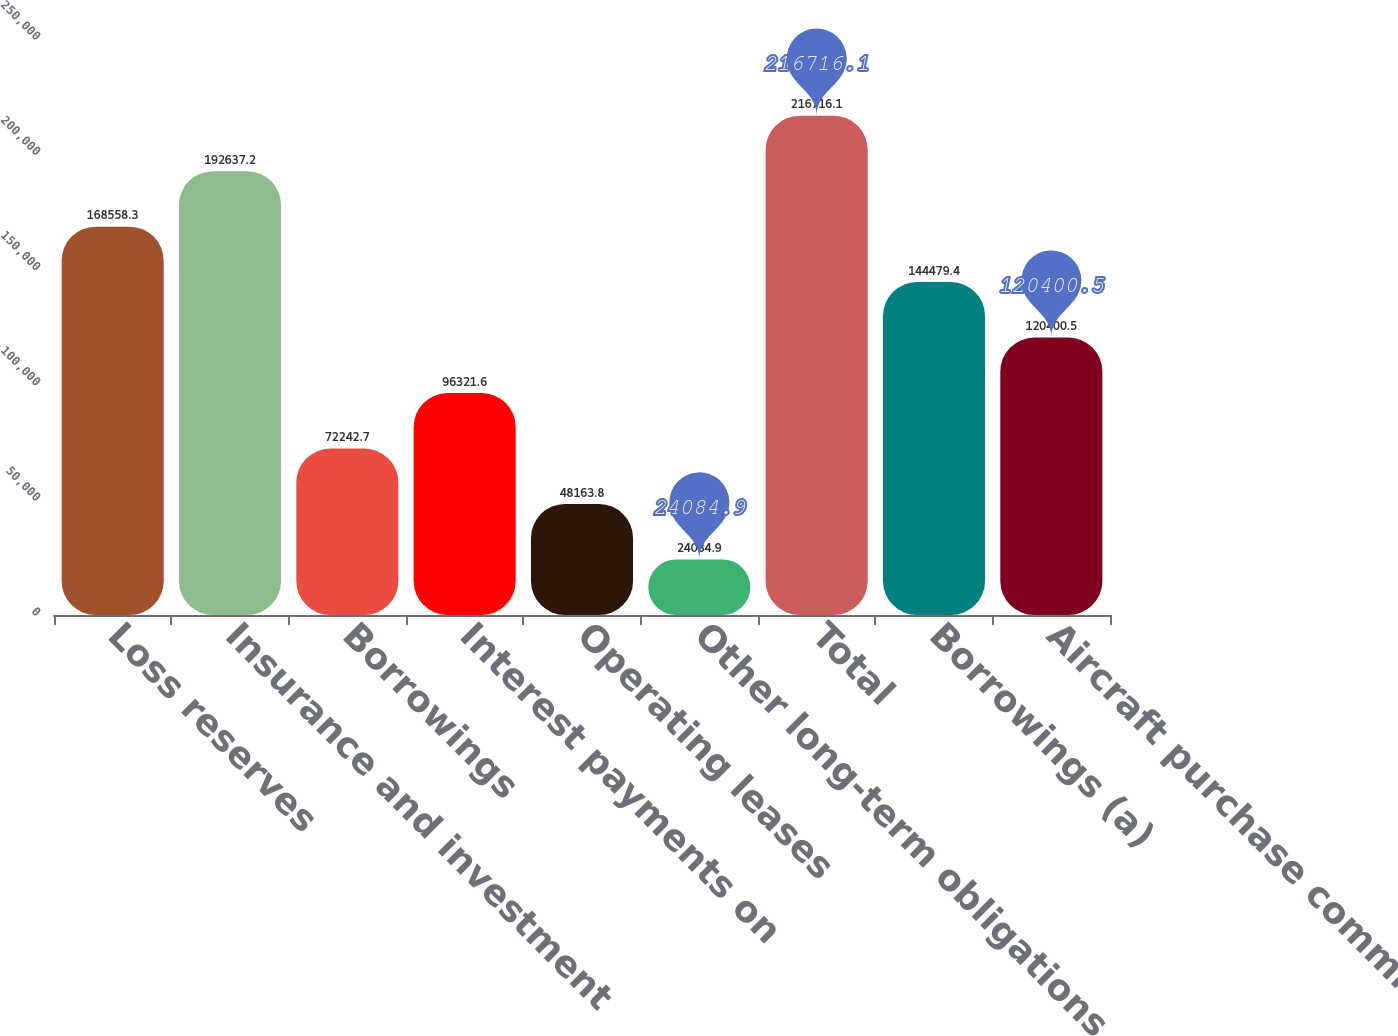Convert chart to OTSL. <chart><loc_0><loc_0><loc_500><loc_500><bar_chart><fcel>Loss reserves<fcel>Insurance and investment<fcel>Borrowings<fcel>Interest payments on<fcel>Operating leases<fcel>Other long-term obligations<fcel>Total<fcel>Borrowings (a)<fcel>Aircraft purchase commitments<nl><fcel>168558<fcel>192637<fcel>72242.7<fcel>96321.6<fcel>48163.8<fcel>24084.9<fcel>216716<fcel>144479<fcel>120400<nl></chart> 